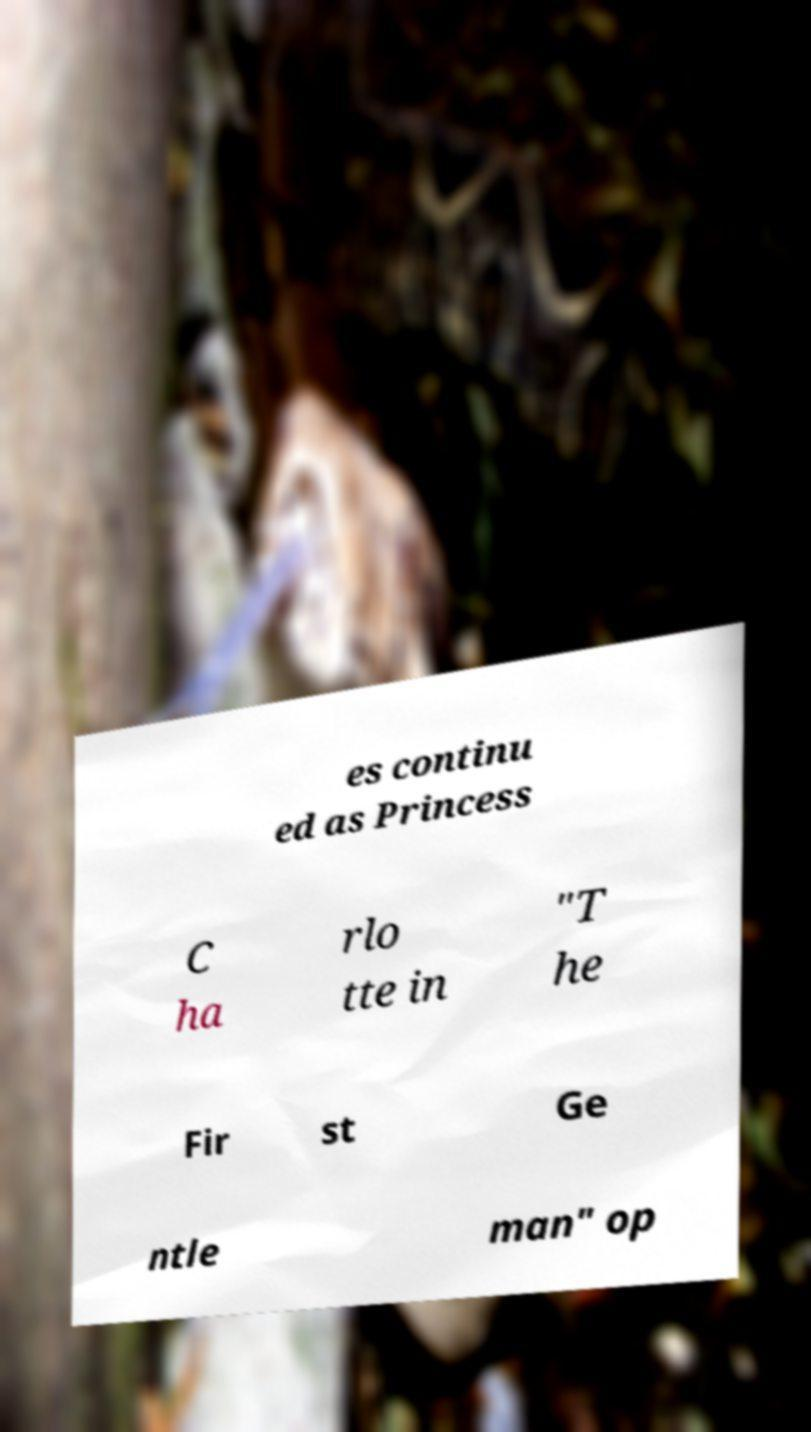Please read and relay the text visible in this image. What does it say? es continu ed as Princess C ha rlo tte in "T he Fir st Ge ntle man" op 